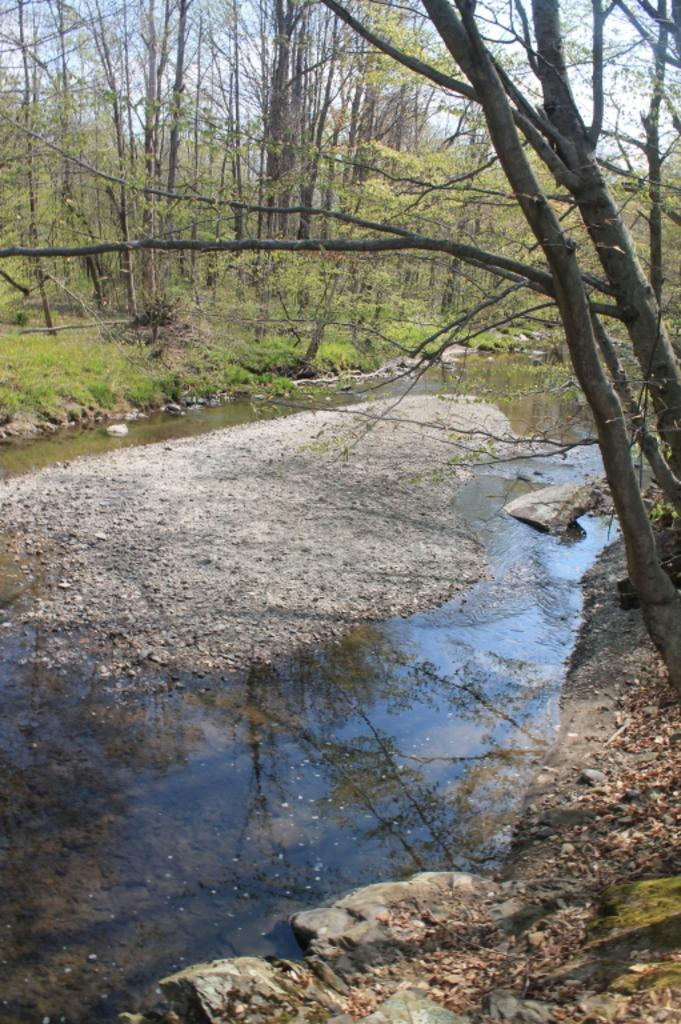What type of water feature is visible in the image? There is a small water canal in the image. What can be seen around the water canal? Trees are present around the water canal. What type of prose is being recited by the father in the image? There is no father or prose present in the image; it only features a small water canal and trees. 